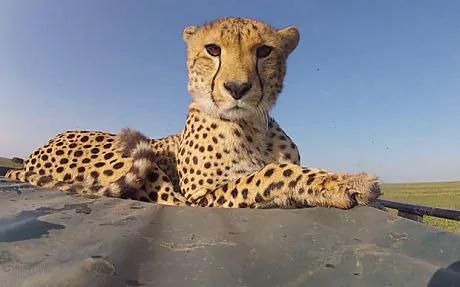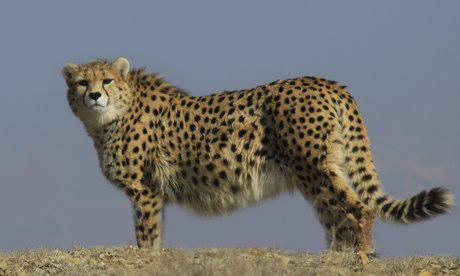The first image is the image on the left, the second image is the image on the right. Given the left and right images, does the statement "Cheetahs are alone, without children, and not running." hold true? Answer yes or no. Yes. 